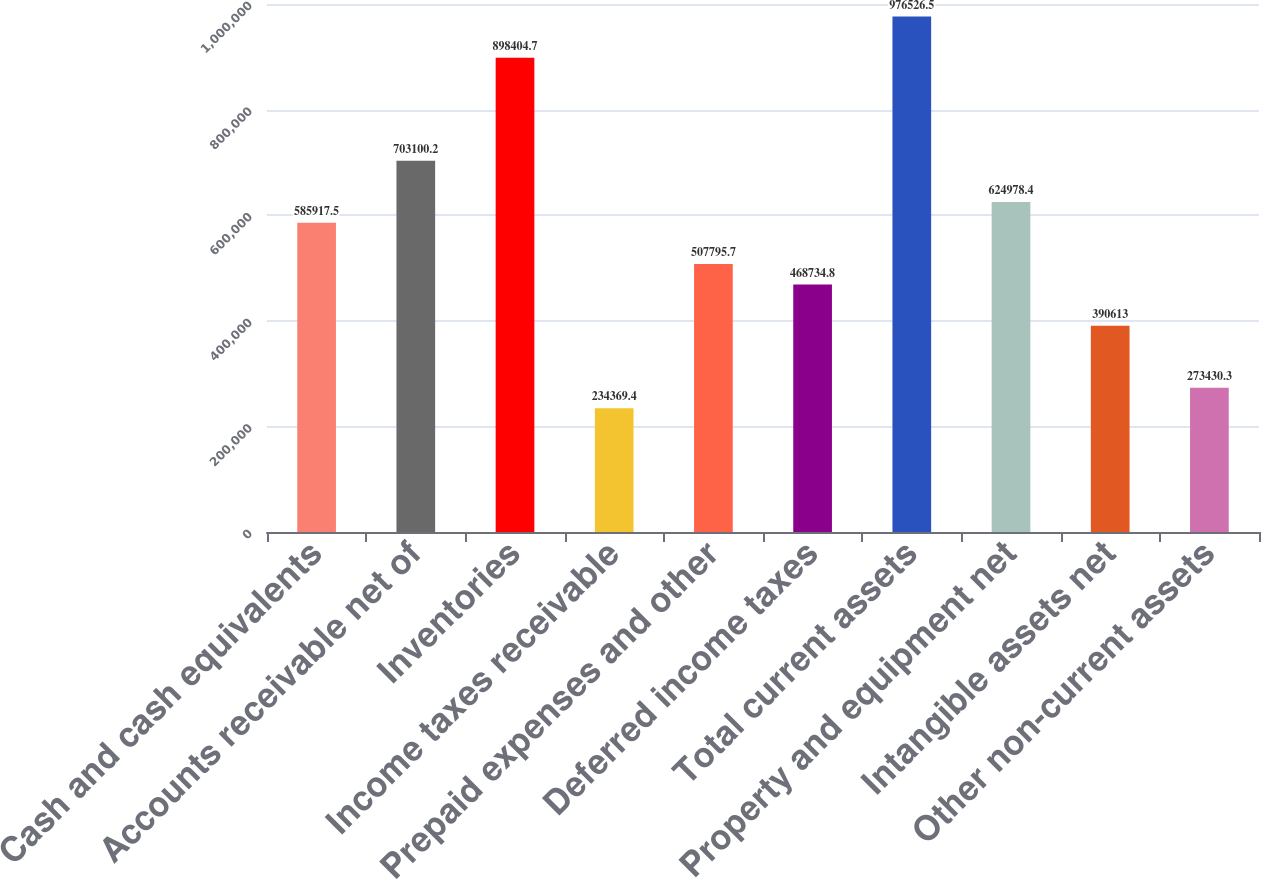Convert chart. <chart><loc_0><loc_0><loc_500><loc_500><bar_chart><fcel>Cash and cash equivalents<fcel>Accounts receivable net of<fcel>Inventories<fcel>Income taxes receivable<fcel>Prepaid expenses and other<fcel>Deferred income taxes<fcel>Total current assets<fcel>Property and equipment net<fcel>Intangible assets net<fcel>Other non-current assets<nl><fcel>585918<fcel>703100<fcel>898405<fcel>234369<fcel>507796<fcel>468735<fcel>976526<fcel>624978<fcel>390613<fcel>273430<nl></chart> 